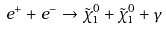<formula> <loc_0><loc_0><loc_500><loc_500>e ^ { + } + e ^ { - } \to \tilde { \chi } _ { 1 } ^ { 0 } + \tilde { \chi } _ { 1 } ^ { 0 } + \gamma</formula> 